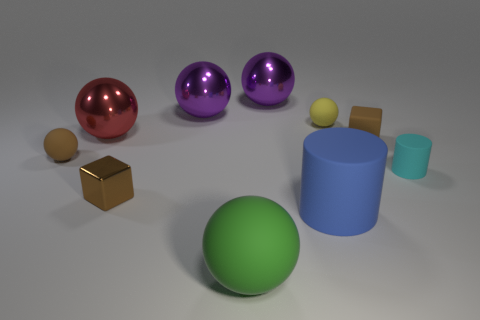Subtract all small brown matte balls. How many balls are left? 5 Subtract all purple spheres. How many spheres are left? 4 Add 1 small purple rubber cubes. How many small purple rubber cubes exist? 1 Subtract 0 blue balls. How many objects are left? 10 Subtract all spheres. How many objects are left? 4 Subtract 2 cylinders. How many cylinders are left? 0 Subtract all blue cubes. Subtract all purple balls. How many cubes are left? 2 Subtract all cyan blocks. How many gray cylinders are left? 0 Subtract all large cylinders. Subtract all green rubber things. How many objects are left? 8 Add 8 large blue cylinders. How many large blue cylinders are left? 9 